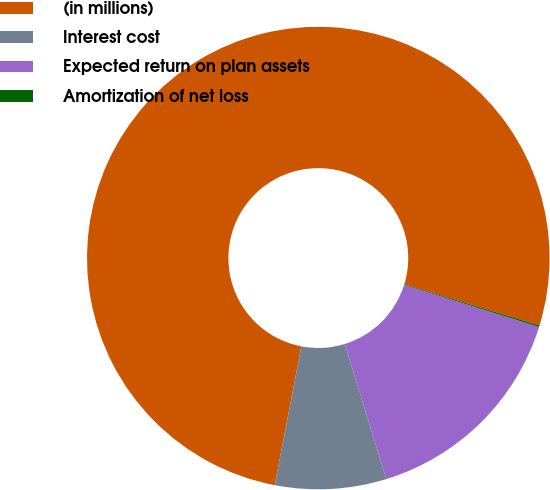Convert chart to OTSL. <chart><loc_0><loc_0><loc_500><loc_500><pie_chart><fcel>(in millions)<fcel>Interest cost<fcel>Expected return on plan assets<fcel>Amortization of net loss<nl><fcel>76.69%<fcel>7.77%<fcel>15.43%<fcel>0.11%<nl></chart> 